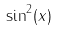<formula> <loc_0><loc_0><loc_500><loc_500>\sin ^ { 2 } ( x )</formula> 